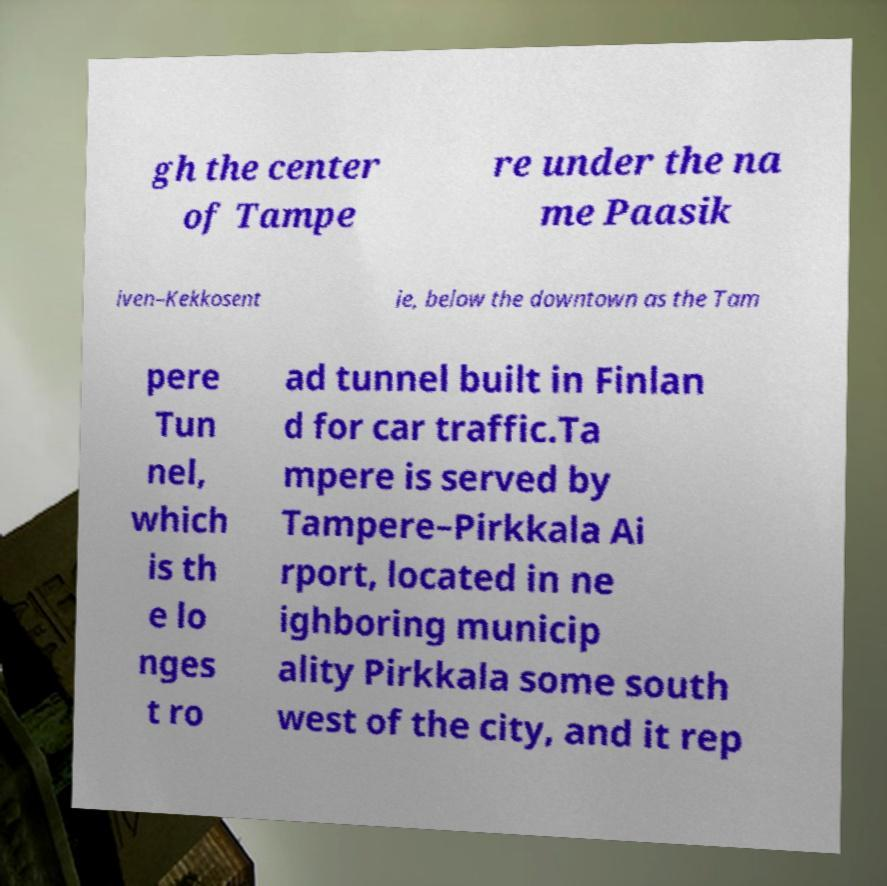Could you extract and type out the text from this image? gh the center of Tampe re under the na me Paasik iven–Kekkosent ie, below the downtown as the Tam pere Tun nel, which is th e lo nges t ro ad tunnel built in Finlan d for car traffic.Ta mpere is served by Tampere–Pirkkala Ai rport, located in ne ighboring municip ality Pirkkala some south west of the city, and it rep 